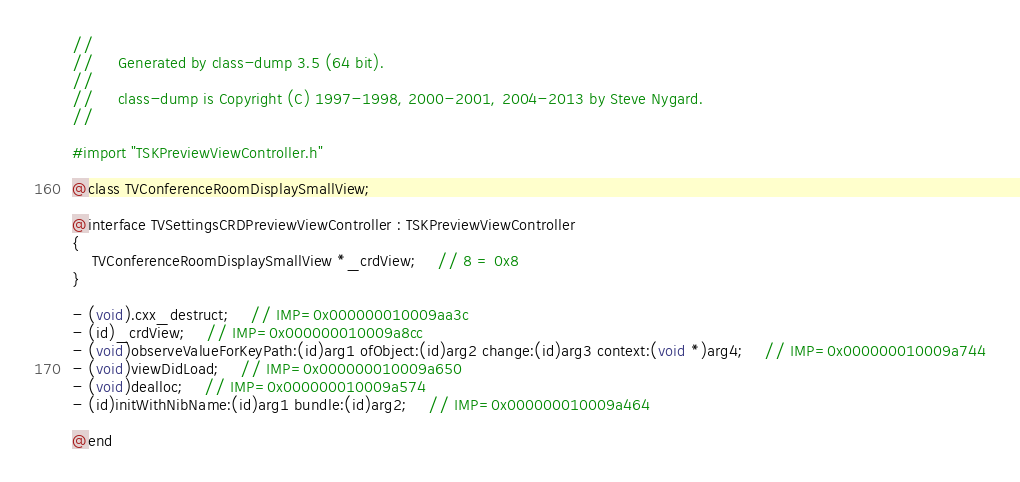Convert code to text. <code><loc_0><loc_0><loc_500><loc_500><_C_>//
//     Generated by class-dump 3.5 (64 bit).
//
//     class-dump is Copyright (C) 1997-1998, 2000-2001, 2004-2013 by Steve Nygard.
//

#import "TSKPreviewViewController.h"

@class TVConferenceRoomDisplaySmallView;

@interface TVSettingsCRDPreviewViewController : TSKPreviewViewController
{
    TVConferenceRoomDisplaySmallView *_crdView;	// 8 = 0x8
}

- (void).cxx_destruct;	// IMP=0x000000010009aa3c
- (id)_crdView;	// IMP=0x000000010009a8cc
- (void)observeValueForKeyPath:(id)arg1 ofObject:(id)arg2 change:(id)arg3 context:(void *)arg4;	// IMP=0x000000010009a744
- (void)viewDidLoad;	// IMP=0x000000010009a650
- (void)dealloc;	// IMP=0x000000010009a574
- (id)initWithNibName:(id)arg1 bundle:(id)arg2;	// IMP=0x000000010009a464

@end

</code> 